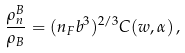<formula> <loc_0><loc_0><loc_500><loc_500>\frac { \rho _ { n } ^ { B } } { \rho _ { B } } = ( n _ { F } b ^ { 3 } ) ^ { 2 / 3 } C ( w , \alpha ) \, ,</formula> 